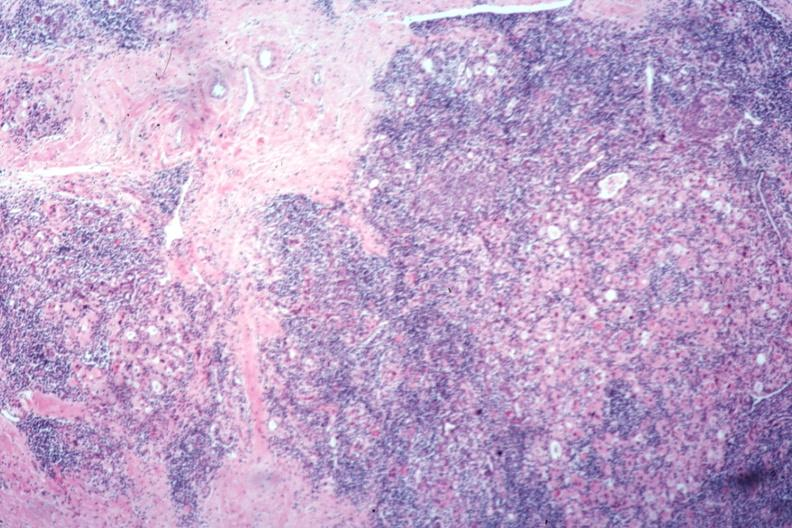s beckwith-wiedemann syndrome present?
Answer the question using a single word or phrase. No 